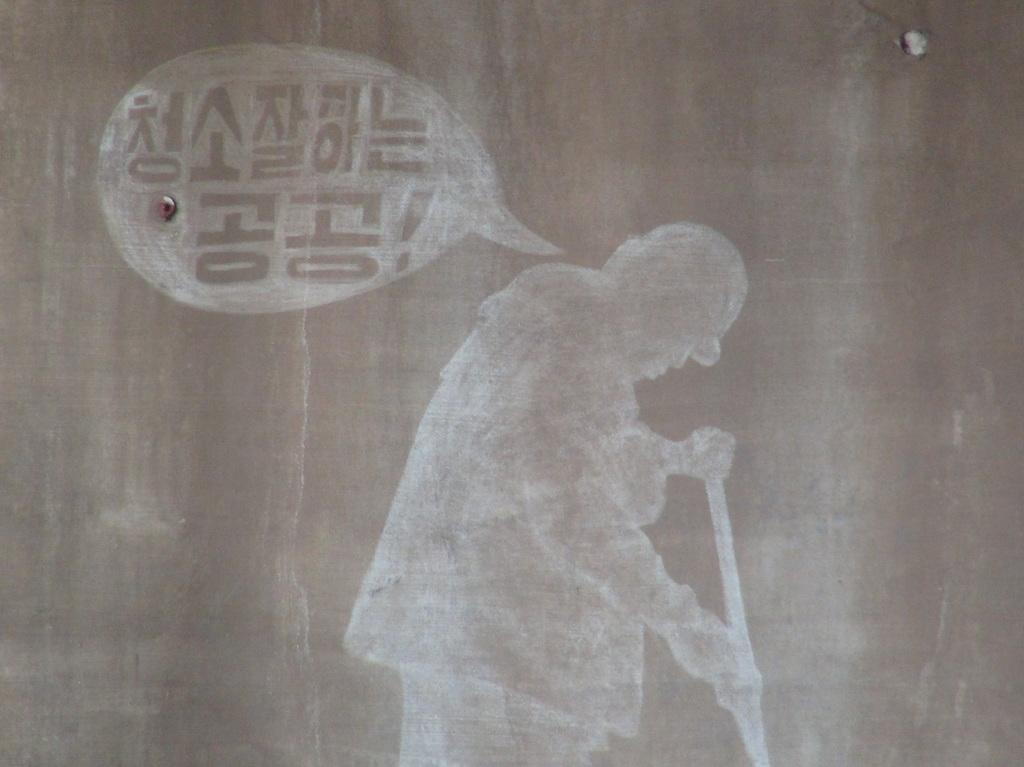What is the main subject of the image? The main subject of the image is a sketch of a person. What is the person holding in the sketch? The person is holding a stick in the sketch. What type of hose is the person using to wash the car in the image? There is no hose or car present in the image; it is a sketch of a person holding a stick. 